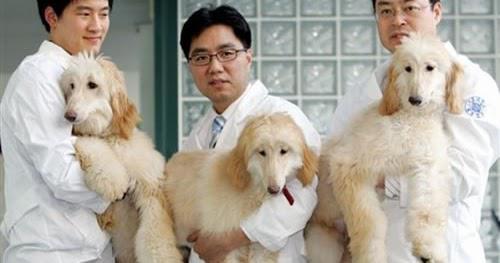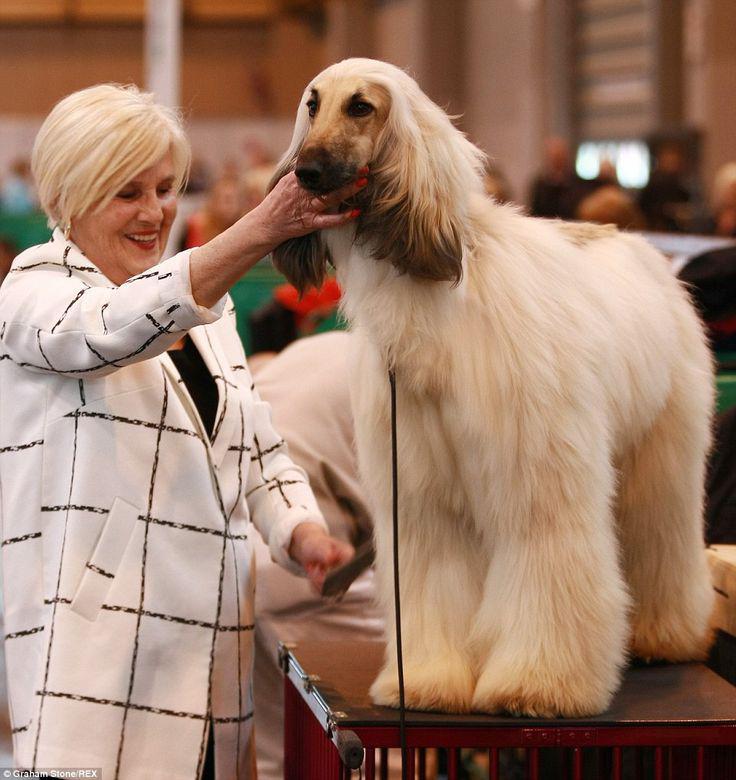The first image is the image on the left, the second image is the image on the right. Evaluate the accuracy of this statement regarding the images: "There are four dogs in total.". Is it true? Answer yes or no. Yes. 